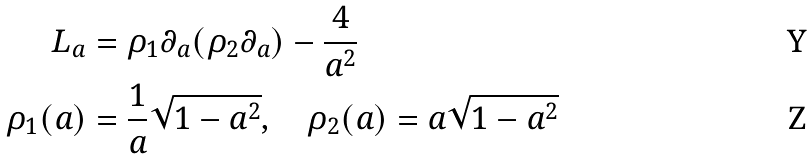<formula> <loc_0><loc_0><loc_500><loc_500>L _ { a } & = \rho _ { 1 } \partial _ { a } ( \rho _ { 2 } \partial _ { a } ) - \frac { 4 } { a ^ { 2 } } \\ \rho _ { 1 } ( a ) & = \frac { 1 } { a } \sqrt { 1 - a ^ { 2 } } , \quad \rho _ { 2 } ( a ) = a \sqrt { 1 - a ^ { 2 } }</formula> 